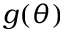Convert formula to latex. <formula><loc_0><loc_0><loc_500><loc_500>g ( \theta )</formula> 